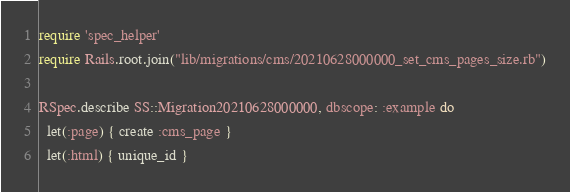<code> <loc_0><loc_0><loc_500><loc_500><_Ruby_>require 'spec_helper'
require Rails.root.join("lib/migrations/cms/20210628000000_set_cms_pages_size.rb")

RSpec.describe SS::Migration20210628000000, dbscope: :example do
  let(:page) { create :cms_page }
  let(:html) { unique_id }
</code> 